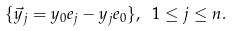Convert formula to latex. <formula><loc_0><loc_0><loc_500><loc_500>\{ \vec { y } _ { j } = y _ { 0 } e _ { j } - y _ { j } e _ { 0 } \} , \ 1 \leq j \leq n .</formula> 